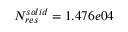<formula> <loc_0><loc_0><loc_500><loc_500>N _ { r e s } ^ { s o l i d } = 1 . 4 7 6 e 0 4</formula> 